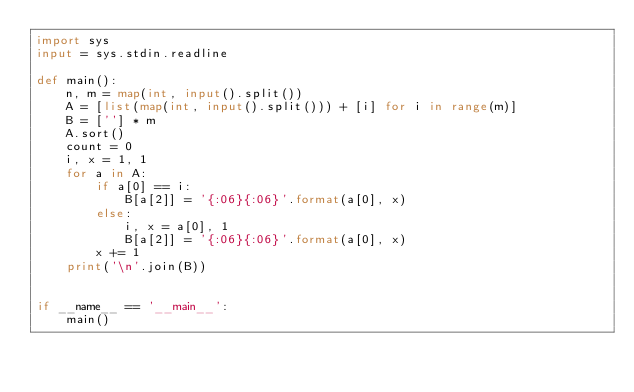Convert code to text. <code><loc_0><loc_0><loc_500><loc_500><_Python_>import sys
input = sys.stdin.readline

def main():
    n, m = map(int, input().split())
    A = [list(map(int, input().split())) + [i] for i in range(m)]
    B = [''] * m
    A.sort()
    count = 0
    i, x = 1, 1
    for a in A:
        if a[0] == i:
            B[a[2]] = '{:06}{:06}'.format(a[0], x)
        else:
            i, x = a[0], 1
            B[a[2]] = '{:06}{:06}'.format(a[0], x)
        x += 1
    print('\n'.join(B))


if __name__ == '__main__':
    main()</code> 